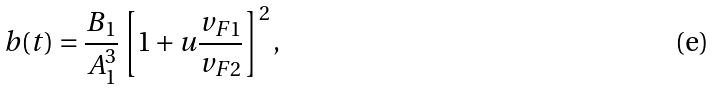<formula> <loc_0><loc_0><loc_500><loc_500>b ( t ) = \frac { B _ { 1 } } { A ^ { 3 } _ { 1 } } \left [ 1 + u \frac { v _ { F 1 } } { v _ { F 2 } } \right ] ^ { 2 } ,</formula> 